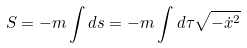Convert formula to latex. <formula><loc_0><loc_0><loc_500><loc_500>S = - m \int d s = - m \int d \tau \sqrt { - \dot { x } ^ { 2 } }</formula> 